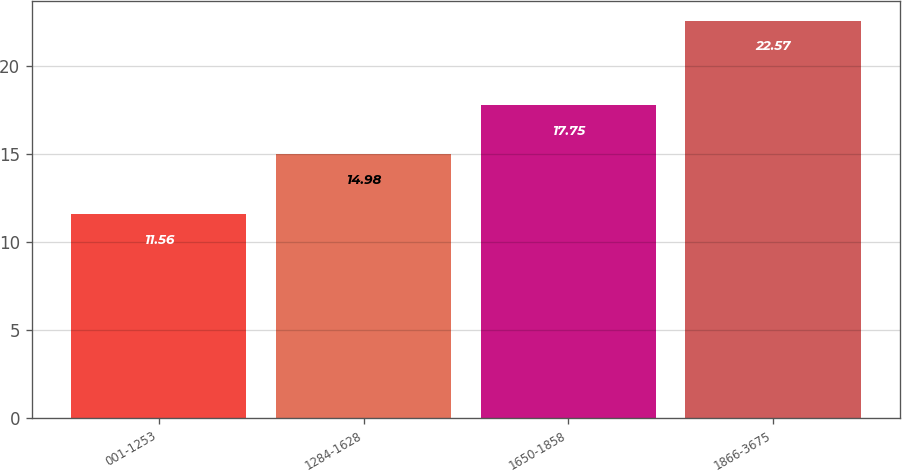<chart> <loc_0><loc_0><loc_500><loc_500><bar_chart><fcel>001-1253<fcel>1284-1628<fcel>1650-1858<fcel>1866-3675<nl><fcel>11.56<fcel>14.98<fcel>17.75<fcel>22.57<nl></chart> 